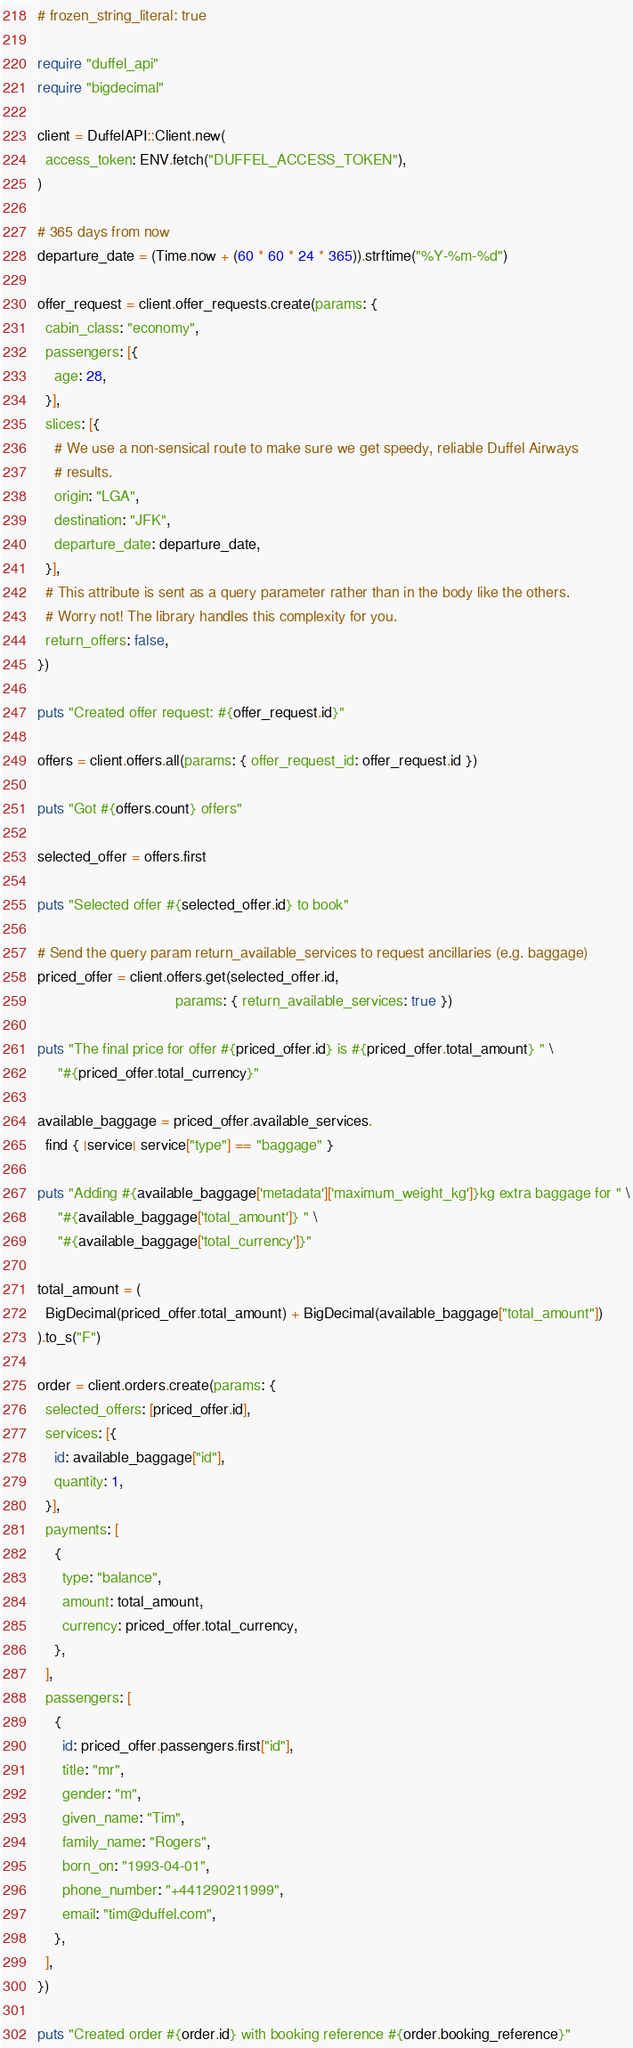<code> <loc_0><loc_0><loc_500><loc_500><_Ruby_># frozen_string_literal: true

require "duffel_api"
require "bigdecimal"

client = DuffelAPI::Client.new(
  access_token: ENV.fetch("DUFFEL_ACCESS_TOKEN"),
)

# 365 days from now
departure_date = (Time.now + (60 * 60 * 24 * 365)).strftime("%Y-%m-%d")

offer_request = client.offer_requests.create(params: {
  cabin_class: "economy",
  passengers: [{
    age: 28,
  }],
  slices: [{
    # We use a non-sensical route to make sure we get speedy, reliable Duffel Airways
    # results.
    origin: "LGA",
    destination: "JFK",
    departure_date: departure_date,
  }],
  # This attribute is sent as a query parameter rather than in the body like the others.
  # Worry not! The library handles this complexity for you.
  return_offers: false,
})

puts "Created offer request: #{offer_request.id}"

offers = client.offers.all(params: { offer_request_id: offer_request.id })

puts "Got #{offers.count} offers"

selected_offer = offers.first

puts "Selected offer #{selected_offer.id} to book"

# Send the query param return_available_services to request ancillaries (e.g. baggage)
priced_offer = client.offers.get(selected_offer.id,
                                 params: { return_available_services: true })

puts "The final price for offer #{priced_offer.id} is #{priced_offer.total_amount} " \
     "#{priced_offer.total_currency}"

available_baggage = priced_offer.available_services.
  find { |service| service["type"] == "baggage" }

puts "Adding #{available_baggage['metadata']['maximum_weight_kg']}kg extra baggage for " \
     "#{available_baggage['total_amount']} " \
     "#{available_baggage['total_currency']}"

total_amount = (
  BigDecimal(priced_offer.total_amount) + BigDecimal(available_baggage["total_amount"])
).to_s("F")

order = client.orders.create(params: {
  selected_offers: [priced_offer.id],
  services: [{
    id: available_baggage["id"],
    quantity: 1,
  }],
  payments: [
    {
      type: "balance",
      amount: total_amount,
      currency: priced_offer.total_currency,
    },
  ],
  passengers: [
    {
      id: priced_offer.passengers.first["id"],
      title: "mr",
      gender: "m",
      given_name: "Tim",
      family_name: "Rogers",
      born_on: "1993-04-01",
      phone_number: "+441290211999",
      email: "tim@duffel.com",
    },
  ],
})

puts "Created order #{order.id} with booking reference #{order.booking_reference}"
</code> 